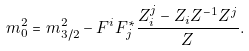Convert formula to latex. <formula><loc_0><loc_0><loc_500><loc_500>m ^ { 2 } _ { 0 } = m _ { 3 / 2 } ^ { 2 } - F ^ { i } F ^ { * } _ { j } \frac { Z _ { i } ^ { j } - Z _ { i } Z ^ { - 1 } Z ^ { j } } { Z } .</formula> 